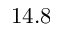<formula> <loc_0><loc_0><loc_500><loc_500>1 4 . 8</formula> 